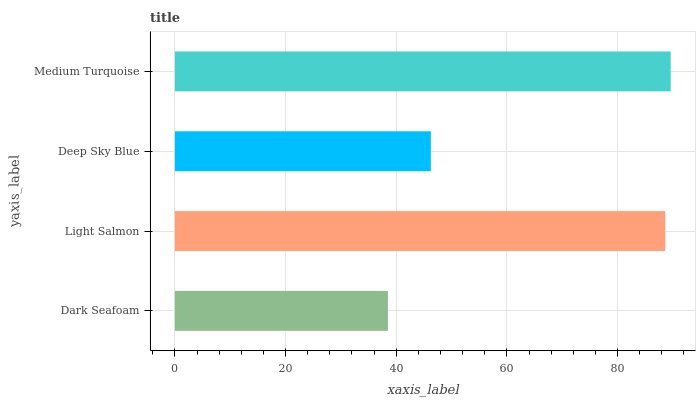Is Dark Seafoam the minimum?
Answer yes or no. Yes. Is Medium Turquoise the maximum?
Answer yes or no. Yes. Is Light Salmon the minimum?
Answer yes or no. No. Is Light Salmon the maximum?
Answer yes or no. No. Is Light Salmon greater than Dark Seafoam?
Answer yes or no. Yes. Is Dark Seafoam less than Light Salmon?
Answer yes or no. Yes. Is Dark Seafoam greater than Light Salmon?
Answer yes or no. No. Is Light Salmon less than Dark Seafoam?
Answer yes or no. No. Is Light Salmon the high median?
Answer yes or no. Yes. Is Deep Sky Blue the low median?
Answer yes or no. Yes. Is Medium Turquoise the high median?
Answer yes or no. No. Is Medium Turquoise the low median?
Answer yes or no. No. 